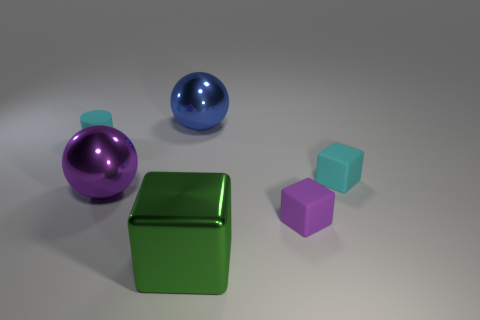Subtract all cyan matte cubes. How many cubes are left? 2 Add 2 tiny red metallic balls. How many objects exist? 8 Subtract 2 balls. How many balls are left? 0 Subtract all spheres. How many objects are left? 4 Subtract all blue balls. How many balls are left? 1 Subtract all green shiny cubes. Subtract all purple balls. How many objects are left? 4 Add 6 large metallic things. How many large metallic things are left? 9 Add 3 tiny purple cubes. How many tiny purple cubes exist? 4 Subtract 0 green spheres. How many objects are left? 6 Subtract all green cylinders. Subtract all gray cubes. How many cylinders are left? 1 